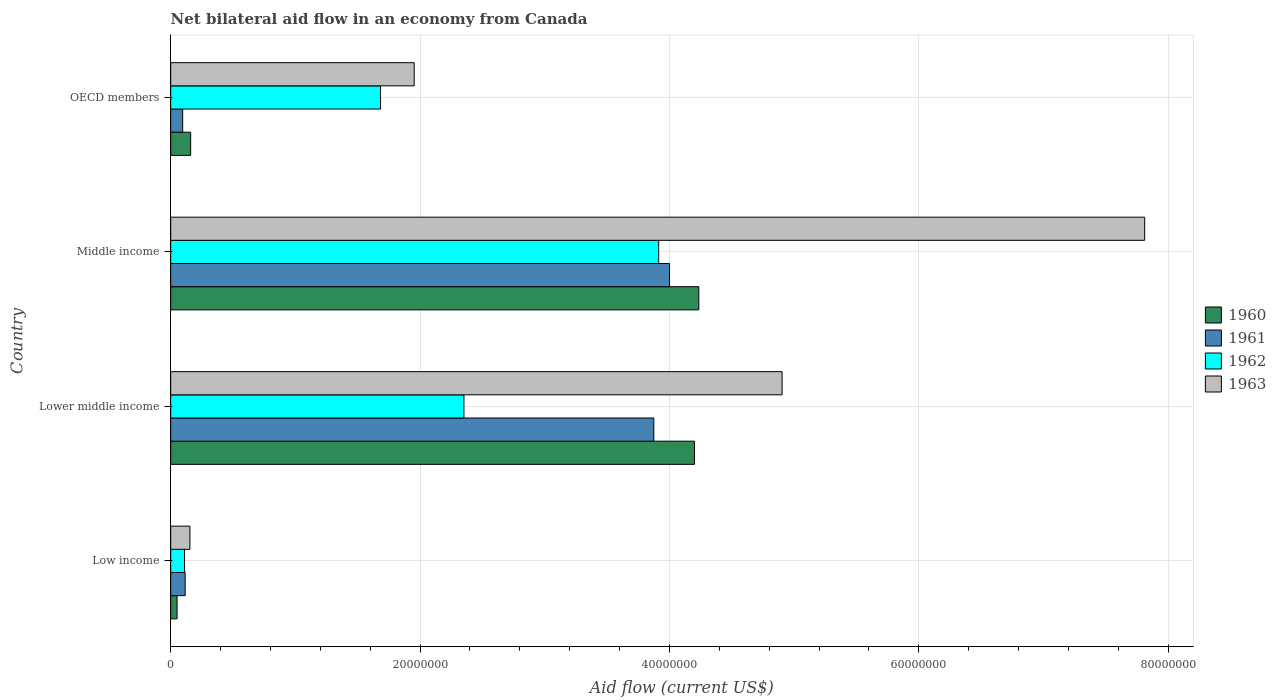How many groups of bars are there?
Keep it short and to the point. 4. How many bars are there on the 1st tick from the top?
Offer a very short reply. 4. In how many cases, is the number of bars for a given country not equal to the number of legend labels?
Your response must be concise. 0. What is the net bilateral aid flow in 1963 in Low income?
Ensure brevity in your answer.  1.54e+06. Across all countries, what is the maximum net bilateral aid flow in 1962?
Make the answer very short. 3.91e+07. Across all countries, what is the minimum net bilateral aid flow in 1962?
Ensure brevity in your answer.  1.11e+06. In which country was the net bilateral aid flow in 1962 maximum?
Offer a very short reply. Middle income. What is the total net bilateral aid flow in 1962 in the graph?
Your response must be concise. 8.06e+07. What is the difference between the net bilateral aid flow in 1963 in Lower middle income and that in Middle income?
Your answer should be very brief. -2.91e+07. What is the difference between the net bilateral aid flow in 1960 in Lower middle income and the net bilateral aid flow in 1963 in Middle income?
Offer a very short reply. -3.61e+07. What is the average net bilateral aid flow in 1963 per country?
Provide a succinct answer. 3.71e+07. What is the difference between the net bilateral aid flow in 1960 and net bilateral aid flow in 1963 in Low income?
Provide a short and direct response. -1.03e+06. In how many countries, is the net bilateral aid flow in 1962 greater than 16000000 US$?
Offer a very short reply. 3. What is the ratio of the net bilateral aid flow in 1961 in Middle income to that in OECD members?
Make the answer very short. 41.68. What is the difference between the highest and the second highest net bilateral aid flow in 1962?
Provide a succinct answer. 1.56e+07. What is the difference between the highest and the lowest net bilateral aid flow in 1962?
Your answer should be very brief. 3.80e+07. In how many countries, is the net bilateral aid flow in 1960 greater than the average net bilateral aid flow in 1960 taken over all countries?
Provide a succinct answer. 2. Is the sum of the net bilateral aid flow in 1961 in Middle income and OECD members greater than the maximum net bilateral aid flow in 1960 across all countries?
Your answer should be compact. No. Is it the case that in every country, the sum of the net bilateral aid flow in 1963 and net bilateral aid flow in 1960 is greater than the sum of net bilateral aid flow in 1962 and net bilateral aid flow in 1961?
Provide a succinct answer. No. What does the 2nd bar from the top in Low income represents?
Give a very brief answer. 1962. Is it the case that in every country, the sum of the net bilateral aid flow in 1961 and net bilateral aid flow in 1962 is greater than the net bilateral aid flow in 1963?
Give a very brief answer. No. Are all the bars in the graph horizontal?
Keep it short and to the point. Yes. What is the difference between two consecutive major ticks on the X-axis?
Your answer should be compact. 2.00e+07. Does the graph contain any zero values?
Ensure brevity in your answer.  No. Where does the legend appear in the graph?
Your response must be concise. Center right. What is the title of the graph?
Keep it short and to the point. Net bilateral aid flow in an economy from Canada. What is the label or title of the X-axis?
Provide a short and direct response. Aid flow (current US$). What is the Aid flow (current US$) of 1960 in Low income?
Ensure brevity in your answer.  5.10e+05. What is the Aid flow (current US$) of 1961 in Low income?
Keep it short and to the point. 1.16e+06. What is the Aid flow (current US$) of 1962 in Low income?
Keep it short and to the point. 1.11e+06. What is the Aid flow (current US$) in 1963 in Low income?
Your answer should be compact. 1.54e+06. What is the Aid flow (current US$) of 1960 in Lower middle income?
Ensure brevity in your answer.  4.20e+07. What is the Aid flow (current US$) of 1961 in Lower middle income?
Provide a short and direct response. 3.88e+07. What is the Aid flow (current US$) in 1962 in Lower middle income?
Provide a short and direct response. 2.35e+07. What is the Aid flow (current US$) in 1963 in Lower middle income?
Make the answer very short. 4.90e+07. What is the Aid flow (current US$) of 1960 in Middle income?
Provide a succinct answer. 4.24e+07. What is the Aid flow (current US$) in 1961 in Middle income?
Offer a terse response. 4.00e+07. What is the Aid flow (current US$) of 1962 in Middle income?
Your answer should be compact. 3.91e+07. What is the Aid flow (current US$) in 1963 in Middle income?
Provide a short and direct response. 7.81e+07. What is the Aid flow (current US$) of 1960 in OECD members?
Make the answer very short. 1.60e+06. What is the Aid flow (current US$) of 1961 in OECD members?
Ensure brevity in your answer.  9.60e+05. What is the Aid flow (current US$) in 1962 in OECD members?
Ensure brevity in your answer.  1.68e+07. What is the Aid flow (current US$) of 1963 in OECD members?
Provide a succinct answer. 1.95e+07. Across all countries, what is the maximum Aid flow (current US$) of 1960?
Give a very brief answer. 4.24e+07. Across all countries, what is the maximum Aid flow (current US$) of 1961?
Offer a very short reply. 4.00e+07. Across all countries, what is the maximum Aid flow (current US$) of 1962?
Provide a short and direct response. 3.91e+07. Across all countries, what is the maximum Aid flow (current US$) of 1963?
Your answer should be very brief. 7.81e+07. Across all countries, what is the minimum Aid flow (current US$) of 1960?
Your answer should be compact. 5.10e+05. Across all countries, what is the minimum Aid flow (current US$) in 1961?
Make the answer very short. 9.60e+05. Across all countries, what is the minimum Aid flow (current US$) in 1962?
Make the answer very short. 1.11e+06. Across all countries, what is the minimum Aid flow (current US$) in 1963?
Provide a short and direct response. 1.54e+06. What is the total Aid flow (current US$) in 1960 in the graph?
Offer a terse response. 8.65e+07. What is the total Aid flow (current US$) of 1961 in the graph?
Ensure brevity in your answer.  8.09e+07. What is the total Aid flow (current US$) of 1962 in the graph?
Your answer should be very brief. 8.06e+07. What is the total Aid flow (current US$) in 1963 in the graph?
Make the answer very short. 1.48e+08. What is the difference between the Aid flow (current US$) in 1960 in Low income and that in Lower middle income?
Keep it short and to the point. -4.15e+07. What is the difference between the Aid flow (current US$) of 1961 in Low income and that in Lower middle income?
Your answer should be compact. -3.76e+07. What is the difference between the Aid flow (current US$) of 1962 in Low income and that in Lower middle income?
Keep it short and to the point. -2.24e+07. What is the difference between the Aid flow (current US$) in 1963 in Low income and that in Lower middle income?
Your answer should be compact. -4.75e+07. What is the difference between the Aid flow (current US$) in 1960 in Low income and that in Middle income?
Make the answer very short. -4.18e+07. What is the difference between the Aid flow (current US$) in 1961 in Low income and that in Middle income?
Offer a very short reply. -3.88e+07. What is the difference between the Aid flow (current US$) of 1962 in Low income and that in Middle income?
Offer a very short reply. -3.80e+07. What is the difference between the Aid flow (current US$) in 1963 in Low income and that in Middle income?
Ensure brevity in your answer.  -7.66e+07. What is the difference between the Aid flow (current US$) in 1960 in Low income and that in OECD members?
Your response must be concise. -1.09e+06. What is the difference between the Aid flow (current US$) in 1962 in Low income and that in OECD members?
Give a very brief answer. -1.57e+07. What is the difference between the Aid flow (current US$) of 1963 in Low income and that in OECD members?
Offer a very short reply. -1.80e+07. What is the difference between the Aid flow (current US$) in 1960 in Lower middle income and that in Middle income?
Your answer should be very brief. -3.50e+05. What is the difference between the Aid flow (current US$) of 1961 in Lower middle income and that in Middle income?
Ensure brevity in your answer.  -1.26e+06. What is the difference between the Aid flow (current US$) in 1962 in Lower middle income and that in Middle income?
Keep it short and to the point. -1.56e+07. What is the difference between the Aid flow (current US$) of 1963 in Lower middle income and that in Middle income?
Make the answer very short. -2.91e+07. What is the difference between the Aid flow (current US$) of 1960 in Lower middle income and that in OECD members?
Ensure brevity in your answer.  4.04e+07. What is the difference between the Aid flow (current US$) in 1961 in Lower middle income and that in OECD members?
Provide a succinct answer. 3.78e+07. What is the difference between the Aid flow (current US$) in 1962 in Lower middle income and that in OECD members?
Your response must be concise. 6.69e+06. What is the difference between the Aid flow (current US$) in 1963 in Lower middle income and that in OECD members?
Offer a terse response. 2.95e+07. What is the difference between the Aid flow (current US$) of 1960 in Middle income and that in OECD members?
Keep it short and to the point. 4.08e+07. What is the difference between the Aid flow (current US$) of 1961 in Middle income and that in OECD members?
Ensure brevity in your answer.  3.90e+07. What is the difference between the Aid flow (current US$) of 1962 in Middle income and that in OECD members?
Your answer should be compact. 2.23e+07. What is the difference between the Aid flow (current US$) of 1963 in Middle income and that in OECD members?
Ensure brevity in your answer.  5.86e+07. What is the difference between the Aid flow (current US$) in 1960 in Low income and the Aid flow (current US$) in 1961 in Lower middle income?
Keep it short and to the point. -3.82e+07. What is the difference between the Aid flow (current US$) in 1960 in Low income and the Aid flow (current US$) in 1962 in Lower middle income?
Your answer should be compact. -2.30e+07. What is the difference between the Aid flow (current US$) of 1960 in Low income and the Aid flow (current US$) of 1963 in Lower middle income?
Make the answer very short. -4.85e+07. What is the difference between the Aid flow (current US$) in 1961 in Low income and the Aid flow (current US$) in 1962 in Lower middle income?
Offer a terse response. -2.24e+07. What is the difference between the Aid flow (current US$) in 1961 in Low income and the Aid flow (current US$) in 1963 in Lower middle income?
Your response must be concise. -4.79e+07. What is the difference between the Aid flow (current US$) in 1962 in Low income and the Aid flow (current US$) in 1963 in Lower middle income?
Offer a very short reply. -4.79e+07. What is the difference between the Aid flow (current US$) in 1960 in Low income and the Aid flow (current US$) in 1961 in Middle income?
Offer a terse response. -3.95e+07. What is the difference between the Aid flow (current US$) in 1960 in Low income and the Aid flow (current US$) in 1962 in Middle income?
Keep it short and to the point. -3.86e+07. What is the difference between the Aid flow (current US$) in 1960 in Low income and the Aid flow (current US$) in 1963 in Middle income?
Provide a short and direct response. -7.76e+07. What is the difference between the Aid flow (current US$) in 1961 in Low income and the Aid flow (current US$) in 1962 in Middle income?
Give a very brief answer. -3.80e+07. What is the difference between the Aid flow (current US$) of 1961 in Low income and the Aid flow (current US$) of 1963 in Middle income?
Offer a very short reply. -7.70e+07. What is the difference between the Aid flow (current US$) in 1962 in Low income and the Aid flow (current US$) in 1963 in Middle income?
Your answer should be compact. -7.70e+07. What is the difference between the Aid flow (current US$) of 1960 in Low income and the Aid flow (current US$) of 1961 in OECD members?
Provide a short and direct response. -4.50e+05. What is the difference between the Aid flow (current US$) of 1960 in Low income and the Aid flow (current US$) of 1962 in OECD members?
Ensure brevity in your answer.  -1.63e+07. What is the difference between the Aid flow (current US$) of 1960 in Low income and the Aid flow (current US$) of 1963 in OECD members?
Ensure brevity in your answer.  -1.90e+07. What is the difference between the Aid flow (current US$) in 1961 in Low income and the Aid flow (current US$) in 1962 in OECD members?
Provide a succinct answer. -1.57e+07. What is the difference between the Aid flow (current US$) of 1961 in Low income and the Aid flow (current US$) of 1963 in OECD members?
Keep it short and to the point. -1.84e+07. What is the difference between the Aid flow (current US$) in 1962 in Low income and the Aid flow (current US$) in 1963 in OECD members?
Your response must be concise. -1.84e+07. What is the difference between the Aid flow (current US$) of 1960 in Lower middle income and the Aid flow (current US$) of 1961 in Middle income?
Your answer should be compact. 2.00e+06. What is the difference between the Aid flow (current US$) of 1960 in Lower middle income and the Aid flow (current US$) of 1962 in Middle income?
Your response must be concise. 2.87e+06. What is the difference between the Aid flow (current US$) in 1960 in Lower middle income and the Aid flow (current US$) in 1963 in Middle income?
Your response must be concise. -3.61e+07. What is the difference between the Aid flow (current US$) in 1961 in Lower middle income and the Aid flow (current US$) in 1962 in Middle income?
Your answer should be compact. -3.90e+05. What is the difference between the Aid flow (current US$) in 1961 in Lower middle income and the Aid flow (current US$) in 1963 in Middle income?
Give a very brief answer. -3.94e+07. What is the difference between the Aid flow (current US$) of 1962 in Lower middle income and the Aid flow (current US$) of 1963 in Middle income?
Offer a very short reply. -5.46e+07. What is the difference between the Aid flow (current US$) in 1960 in Lower middle income and the Aid flow (current US$) in 1961 in OECD members?
Make the answer very short. 4.10e+07. What is the difference between the Aid flow (current US$) in 1960 in Lower middle income and the Aid flow (current US$) in 1962 in OECD members?
Give a very brief answer. 2.52e+07. What is the difference between the Aid flow (current US$) of 1960 in Lower middle income and the Aid flow (current US$) of 1963 in OECD members?
Ensure brevity in your answer.  2.25e+07. What is the difference between the Aid flow (current US$) in 1961 in Lower middle income and the Aid flow (current US$) in 1962 in OECD members?
Provide a succinct answer. 2.19e+07. What is the difference between the Aid flow (current US$) of 1961 in Lower middle income and the Aid flow (current US$) of 1963 in OECD members?
Keep it short and to the point. 1.92e+07. What is the difference between the Aid flow (current US$) of 1962 in Lower middle income and the Aid flow (current US$) of 1963 in OECD members?
Offer a very short reply. 3.99e+06. What is the difference between the Aid flow (current US$) in 1960 in Middle income and the Aid flow (current US$) in 1961 in OECD members?
Provide a short and direct response. 4.14e+07. What is the difference between the Aid flow (current US$) in 1960 in Middle income and the Aid flow (current US$) in 1962 in OECD members?
Make the answer very short. 2.55e+07. What is the difference between the Aid flow (current US$) of 1960 in Middle income and the Aid flow (current US$) of 1963 in OECD members?
Your answer should be compact. 2.28e+07. What is the difference between the Aid flow (current US$) of 1961 in Middle income and the Aid flow (current US$) of 1962 in OECD members?
Offer a terse response. 2.32e+07. What is the difference between the Aid flow (current US$) of 1961 in Middle income and the Aid flow (current US$) of 1963 in OECD members?
Give a very brief answer. 2.05e+07. What is the difference between the Aid flow (current US$) of 1962 in Middle income and the Aid flow (current US$) of 1963 in OECD members?
Provide a short and direct response. 1.96e+07. What is the average Aid flow (current US$) of 1960 per country?
Provide a short and direct response. 2.16e+07. What is the average Aid flow (current US$) of 1961 per country?
Your response must be concise. 2.02e+07. What is the average Aid flow (current US$) in 1962 per country?
Offer a terse response. 2.02e+07. What is the average Aid flow (current US$) in 1963 per country?
Your response must be concise. 3.71e+07. What is the difference between the Aid flow (current US$) of 1960 and Aid flow (current US$) of 1961 in Low income?
Keep it short and to the point. -6.50e+05. What is the difference between the Aid flow (current US$) of 1960 and Aid flow (current US$) of 1962 in Low income?
Give a very brief answer. -6.00e+05. What is the difference between the Aid flow (current US$) in 1960 and Aid flow (current US$) in 1963 in Low income?
Your response must be concise. -1.03e+06. What is the difference between the Aid flow (current US$) of 1961 and Aid flow (current US$) of 1962 in Low income?
Provide a succinct answer. 5.00e+04. What is the difference between the Aid flow (current US$) in 1961 and Aid flow (current US$) in 1963 in Low income?
Ensure brevity in your answer.  -3.80e+05. What is the difference between the Aid flow (current US$) of 1962 and Aid flow (current US$) of 1963 in Low income?
Keep it short and to the point. -4.30e+05. What is the difference between the Aid flow (current US$) of 1960 and Aid flow (current US$) of 1961 in Lower middle income?
Provide a succinct answer. 3.26e+06. What is the difference between the Aid flow (current US$) of 1960 and Aid flow (current US$) of 1962 in Lower middle income?
Provide a short and direct response. 1.85e+07. What is the difference between the Aid flow (current US$) in 1960 and Aid flow (current US$) in 1963 in Lower middle income?
Make the answer very short. -7.03e+06. What is the difference between the Aid flow (current US$) in 1961 and Aid flow (current US$) in 1962 in Lower middle income?
Give a very brief answer. 1.52e+07. What is the difference between the Aid flow (current US$) in 1961 and Aid flow (current US$) in 1963 in Lower middle income?
Your answer should be very brief. -1.03e+07. What is the difference between the Aid flow (current US$) of 1962 and Aid flow (current US$) of 1963 in Lower middle income?
Your response must be concise. -2.55e+07. What is the difference between the Aid flow (current US$) in 1960 and Aid flow (current US$) in 1961 in Middle income?
Offer a very short reply. 2.35e+06. What is the difference between the Aid flow (current US$) of 1960 and Aid flow (current US$) of 1962 in Middle income?
Ensure brevity in your answer.  3.22e+06. What is the difference between the Aid flow (current US$) of 1960 and Aid flow (current US$) of 1963 in Middle income?
Provide a succinct answer. -3.58e+07. What is the difference between the Aid flow (current US$) in 1961 and Aid flow (current US$) in 1962 in Middle income?
Make the answer very short. 8.70e+05. What is the difference between the Aid flow (current US$) of 1961 and Aid flow (current US$) of 1963 in Middle income?
Your answer should be compact. -3.81e+07. What is the difference between the Aid flow (current US$) in 1962 and Aid flow (current US$) in 1963 in Middle income?
Provide a short and direct response. -3.90e+07. What is the difference between the Aid flow (current US$) in 1960 and Aid flow (current US$) in 1961 in OECD members?
Offer a very short reply. 6.40e+05. What is the difference between the Aid flow (current US$) in 1960 and Aid flow (current US$) in 1962 in OECD members?
Provide a succinct answer. -1.52e+07. What is the difference between the Aid flow (current US$) of 1960 and Aid flow (current US$) of 1963 in OECD members?
Keep it short and to the point. -1.79e+07. What is the difference between the Aid flow (current US$) in 1961 and Aid flow (current US$) in 1962 in OECD members?
Provide a short and direct response. -1.59e+07. What is the difference between the Aid flow (current US$) in 1961 and Aid flow (current US$) in 1963 in OECD members?
Provide a short and direct response. -1.86e+07. What is the difference between the Aid flow (current US$) in 1962 and Aid flow (current US$) in 1963 in OECD members?
Your response must be concise. -2.70e+06. What is the ratio of the Aid flow (current US$) in 1960 in Low income to that in Lower middle income?
Provide a succinct answer. 0.01. What is the ratio of the Aid flow (current US$) of 1961 in Low income to that in Lower middle income?
Offer a very short reply. 0.03. What is the ratio of the Aid flow (current US$) of 1962 in Low income to that in Lower middle income?
Keep it short and to the point. 0.05. What is the ratio of the Aid flow (current US$) in 1963 in Low income to that in Lower middle income?
Offer a terse response. 0.03. What is the ratio of the Aid flow (current US$) in 1960 in Low income to that in Middle income?
Your answer should be compact. 0.01. What is the ratio of the Aid flow (current US$) of 1961 in Low income to that in Middle income?
Offer a very short reply. 0.03. What is the ratio of the Aid flow (current US$) of 1962 in Low income to that in Middle income?
Your answer should be very brief. 0.03. What is the ratio of the Aid flow (current US$) of 1963 in Low income to that in Middle income?
Offer a very short reply. 0.02. What is the ratio of the Aid flow (current US$) of 1960 in Low income to that in OECD members?
Your answer should be very brief. 0.32. What is the ratio of the Aid flow (current US$) in 1961 in Low income to that in OECD members?
Your response must be concise. 1.21. What is the ratio of the Aid flow (current US$) of 1962 in Low income to that in OECD members?
Offer a terse response. 0.07. What is the ratio of the Aid flow (current US$) in 1963 in Low income to that in OECD members?
Your answer should be compact. 0.08. What is the ratio of the Aid flow (current US$) in 1961 in Lower middle income to that in Middle income?
Your answer should be very brief. 0.97. What is the ratio of the Aid flow (current US$) of 1962 in Lower middle income to that in Middle income?
Your answer should be compact. 0.6. What is the ratio of the Aid flow (current US$) of 1963 in Lower middle income to that in Middle income?
Keep it short and to the point. 0.63. What is the ratio of the Aid flow (current US$) of 1960 in Lower middle income to that in OECD members?
Offer a terse response. 26.26. What is the ratio of the Aid flow (current US$) of 1961 in Lower middle income to that in OECD members?
Make the answer very short. 40.36. What is the ratio of the Aid flow (current US$) in 1962 in Lower middle income to that in OECD members?
Provide a short and direct response. 1.4. What is the ratio of the Aid flow (current US$) in 1963 in Lower middle income to that in OECD members?
Ensure brevity in your answer.  2.51. What is the ratio of the Aid flow (current US$) in 1960 in Middle income to that in OECD members?
Your answer should be compact. 26.48. What is the ratio of the Aid flow (current US$) of 1961 in Middle income to that in OECD members?
Offer a very short reply. 41.68. What is the ratio of the Aid flow (current US$) in 1962 in Middle income to that in OECD members?
Offer a very short reply. 2.33. What is the ratio of the Aid flow (current US$) of 1963 in Middle income to that in OECD members?
Keep it short and to the point. 4. What is the difference between the highest and the second highest Aid flow (current US$) in 1960?
Provide a succinct answer. 3.50e+05. What is the difference between the highest and the second highest Aid flow (current US$) of 1961?
Keep it short and to the point. 1.26e+06. What is the difference between the highest and the second highest Aid flow (current US$) in 1962?
Keep it short and to the point. 1.56e+07. What is the difference between the highest and the second highest Aid flow (current US$) in 1963?
Make the answer very short. 2.91e+07. What is the difference between the highest and the lowest Aid flow (current US$) of 1960?
Ensure brevity in your answer.  4.18e+07. What is the difference between the highest and the lowest Aid flow (current US$) of 1961?
Keep it short and to the point. 3.90e+07. What is the difference between the highest and the lowest Aid flow (current US$) in 1962?
Ensure brevity in your answer.  3.80e+07. What is the difference between the highest and the lowest Aid flow (current US$) of 1963?
Offer a very short reply. 7.66e+07. 